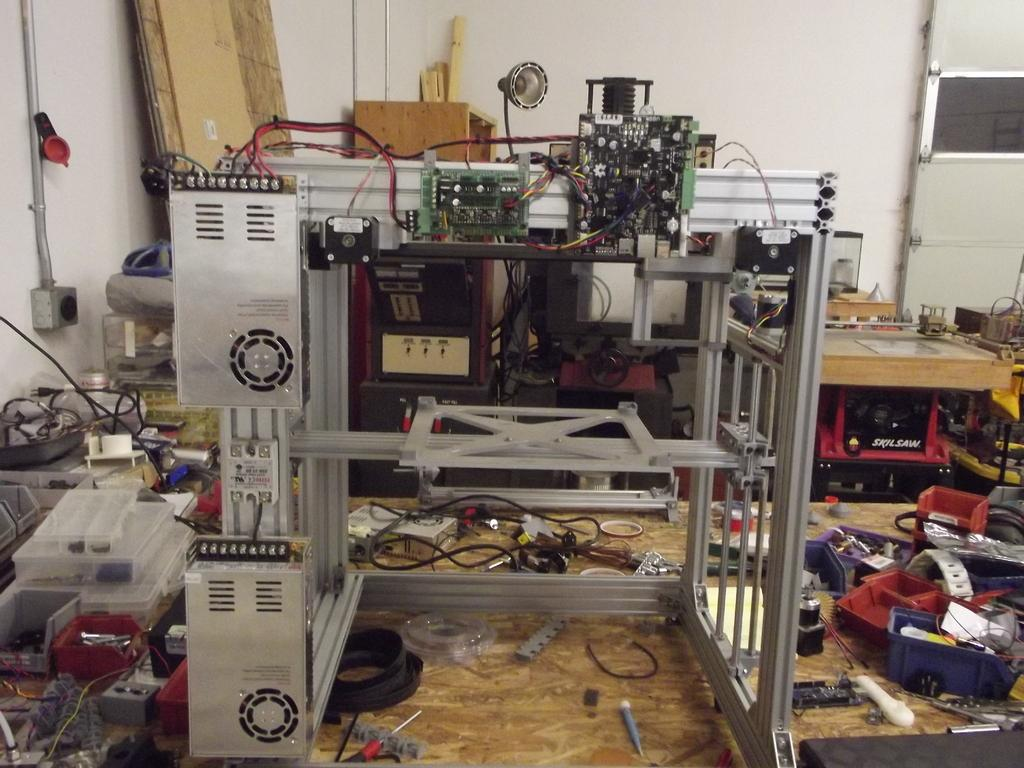What type of objects can be seen in the image? There are machine parts and cable wires visible in the image. What else can be seen on the floor in the image? There are boxes on the floor in the image. What is the color of the wall visible at the top of the image? The wall visible at the top of the image is white. What part of the room is visible in the image? The floor is visible in the image. What type of bird can be seen singing on the machine parts in the image? There are no birds visible in the image, so it is not possible to determine if a bird is singing on the machine parts. 